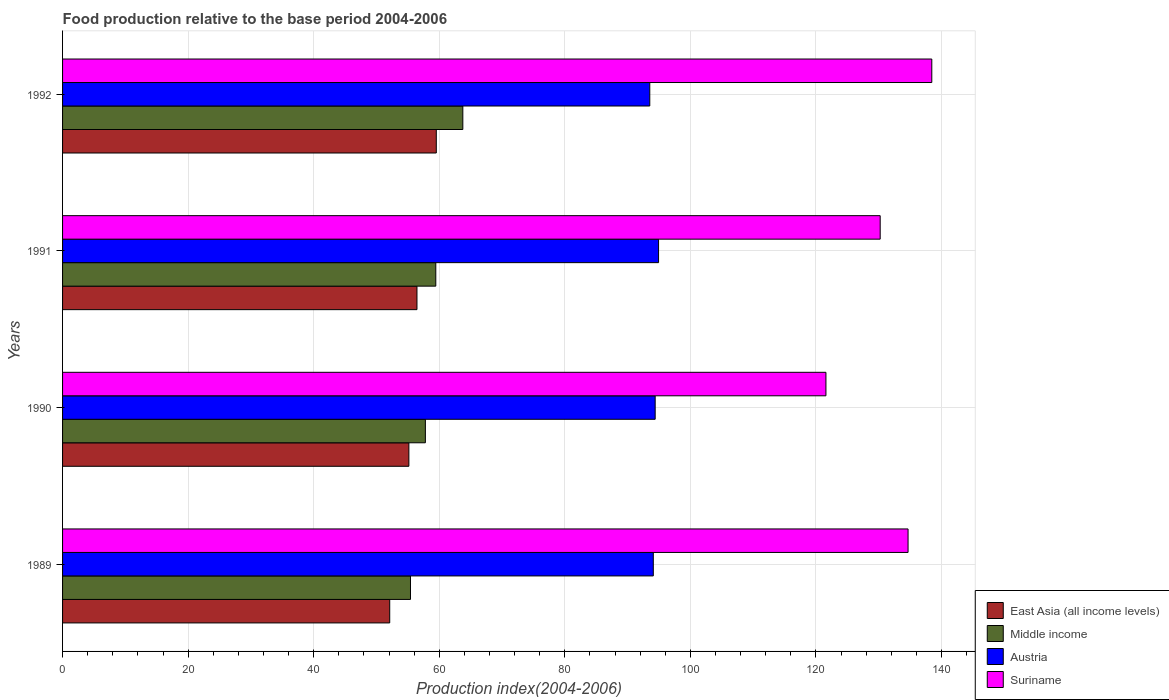How many groups of bars are there?
Your response must be concise. 4. Are the number of bars per tick equal to the number of legend labels?
Provide a short and direct response. Yes. Are the number of bars on each tick of the Y-axis equal?
Your answer should be very brief. Yes. How many bars are there on the 3rd tick from the top?
Offer a terse response. 4. What is the food production index in Suriname in 1991?
Offer a very short reply. 130.23. Across all years, what is the maximum food production index in East Asia (all income levels)?
Keep it short and to the point. 59.53. Across all years, what is the minimum food production index in Austria?
Your answer should be very brief. 93.53. What is the total food production index in Austria in the graph?
Keep it short and to the point. 376.94. What is the difference between the food production index in East Asia (all income levels) in 1991 and that in 1992?
Provide a succinct answer. -3.08. What is the difference between the food production index in Suriname in 1991 and the food production index in East Asia (all income levels) in 1989?
Offer a terse response. 78.12. What is the average food production index in Suriname per year?
Your answer should be compact. 131.24. In the year 1990, what is the difference between the food production index in Middle income and food production index in Austria?
Your response must be concise. -36.6. What is the ratio of the food production index in Suriname in 1990 to that in 1991?
Keep it short and to the point. 0.93. Is the difference between the food production index in Middle income in 1990 and 1991 greater than the difference between the food production index in Austria in 1990 and 1991?
Offer a very short reply. No. What is the difference between the highest and the second highest food production index in Suriname?
Offer a terse response. 3.78. What is the difference between the highest and the lowest food production index in Suriname?
Give a very brief answer. 16.86. Is the sum of the food production index in Middle income in 1989 and 1990 greater than the maximum food production index in Suriname across all years?
Provide a short and direct response. No. Is it the case that in every year, the sum of the food production index in Middle income and food production index in East Asia (all income levels) is greater than the sum of food production index in Suriname and food production index in Austria?
Your response must be concise. No. What does the 4th bar from the top in 1989 represents?
Make the answer very short. East Asia (all income levels). What does the 1st bar from the bottom in 1990 represents?
Make the answer very short. East Asia (all income levels). How many years are there in the graph?
Your answer should be very brief. 4. What is the difference between two consecutive major ticks on the X-axis?
Offer a very short reply. 20. Are the values on the major ticks of X-axis written in scientific E-notation?
Provide a short and direct response. No. How many legend labels are there?
Your response must be concise. 4. What is the title of the graph?
Keep it short and to the point. Food production relative to the base period 2004-2006. What is the label or title of the X-axis?
Ensure brevity in your answer.  Production index(2004-2006). What is the Production index(2004-2006) of East Asia (all income levels) in 1989?
Ensure brevity in your answer.  52.11. What is the Production index(2004-2006) of Middle income in 1989?
Your answer should be compact. 55.42. What is the Production index(2004-2006) in Austria in 1989?
Ensure brevity in your answer.  94.09. What is the Production index(2004-2006) in Suriname in 1989?
Keep it short and to the point. 134.67. What is the Production index(2004-2006) of East Asia (all income levels) in 1990?
Offer a terse response. 55.16. What is the Production index(2004-2006) of Middle income in 1990?
Provide a succinct answer. 57.79. What is the Production index(2004-2006) in Austria in 1990?
Give a very brief answer. 94.39. What is the Production index(2004-2006) of Suriname in 1990?
Your answer should be compact. 121.59. What is the Production index(2004-2006) of East Asia (all income levels) in 1991?
Provide a short and direct response. 56.45. What is the Production index(2004-2006) of Middle income in 1991?
Give a very brief answer. 59.45. What is the Production index(2004-2006) in Austria in 1991?
Give a very brief answer. 94.93. What is the Production index(2004-2006) of Suriname in 1991?
Your answer should be compact. 130.23. What is the Production index(2004-2006) of East Asia (all income levels) in 1992?
Provide a succinct answer. 59.53. What is the Production index(2004-2006) in Middle income in 1992?
Give a very brief answer. 63.75. What is the Production index(2004-2006) of Austria in 1992?
Provide a short and direct response. 93.53. What is the Production index(2004-2006) in Suriname in 1992?
Offer a terse response. 138.45. Across all years, what is the maximum Production index(2004-2006) in East Asia (all income levels)?
Offer a very short reply. 59.53. Across all years, what is the maximum Production index(2004-2006) of Middle income?
Make the answer very short. 63.75. Across all years, what is the maximum Production index(2004-2006) in Austria?
Make the answer very short. 94.93. Across all years, what is the maximum Production index(2004-2006) of Suriname?
Offer a very short reply. 138.45. Across all years, what is the minimum Production index(2004-2006) in East Asia (all income levels)?
Offer a very short reply. 52.11. Across all years, what is the minimum Production index(2004-2006) in Middle income?
Provide a short and direct response. 55.42. Across all years, what is the minimum Production index(2004-2006) in Austria?
Offer a very short reply. 93.53. Across all years, what is the minimum Production index(2004-2006) of Suriname?
Offer a very short reply. 121.59. What is the total Production index(2004-2006) in East Asia (all income levels) in the graph?
Your answer should be compact. 223.24. What is the total Production index(2004-2006) in Middle income in the graph?
Give a very brief answer. 236.41. What is the total Production index(2004-2006) in Austria in the graph?
Provide a short and direct response. 376.94. What is the total Production index(2004-2006) in Suriname in the graph?
Offer a very short reply. 524.94. What is the difference between the Production index(2004-2006) of East Asia (all income levels) in 1989 and that in 1990?
Give a very brief answer. -3.05. What is the difference between the Production index(2004-2006) of Middle income in 1989 and that in 1990?
Provide a short and direct response. -2.37. What is the difference between the Production index(2004-2006) in Suriname in 1989 and that in 1990?
Provide a succinct answer. 13.08. What is the difference between the Production index(2004-2006) of East Asia (all income levels) in 1989 and that in 1991?
Provide a short and direct response. -4.34. What is the difference between the Production index(2004-2006) in Middle income in 1989 and that in 1991?
Your answer should be very brief. -4.03. What is the difference between the Production index(2004-2006) of Austria in 1989 and that in 1991?
Your answer should be compact. -0.84. What is the difference between the Production index(2004-2006) in Suriname in 1989 and that in 1991?
Make the answer very short. 4.44. What is the difference between the Production index(2004-2006) in East Asia (all income levels) in 1989 and that in 1992?
Ensure brevity in your answer.  -7.42. What is the difference between the Production index(2004-2006) of Middle income in 1989 and that in 1992?
Provide a short and direct response. -8.34. What is the difference between the Production index(2004-2006) of Austria in 1989 and that in 1992?
Your answer should be compact. 0.56. What is the difference between the Production index(2004-2006) in Suriname in 1989 and that in 1992?
Your response must be concise. -3.78. What is the difference between the Production index(2004-2006) of East Asia (all income levels) in 1990 and that in 1991?
Provide a succinct answer. -1.29. What is the difference between the Production index(2004-2006) in Middle income in 1990 and that in 1991?
Offer a very short reply. -1.66. What is the difference between the Production index(2004-2006) of Austria in 1990 and that in 1991?
Your answer should be very brief. -0.54. What is the difference between the Production index(2004-2006) of Suriname in 1990 and that in 1991?
Provide a succinct answer. -8.64. What is the difference between the Production index(2004-2006) in East Asia (all income levels) in 1990 and that in 1992?
Provide a short and direct response. -4.37. What is the difference between the Production index(2004-2006) of Middle income in 1990 and that in 1992?
Your answer should be very brief. -5.97. What is the difference between the Production index(2004-2006) in Austria in 1990 and that in 1992?
Your answer should be compact. 0.86. What is the difference between the Production index(2004-2006) of Suriname in 1990 and that in 1992?
Your answer should be compact. -16.86. What is the difference between the Production index(2004-2006) in East Asia (all income levels) in 1991 and that in 1992?
Give a very brief answer. -3.08. What is the difference between the Production index(2004-2006) of Middle income in 1991 and that in 1992?
Ensure brevity in your answer.  -4.3. What is the difference between the Production index(2004-2006) in Austria in 1991 and that in 1992?
Give a very brief answer. 1.4. What is the difference between the Production index(2004-2006) of Suriname in 1991 and that in 1992?
Make the answer very short. -8.22. What is the difference between the Production index(2004-2006) of East Asia (all income levels) in 1989 and the Production index(2004-2006) of Middle income in 1990?
Offer a very short reply. -5.68. What is the difference between the Production index(2004-2006) of East Asia (all income levels) in 1989 and the Production index(2004-2006) of Austria in 1990?
Provide a succinct answer. -42.28. What is the difference between the Production index(2004-2006) in East Asia (all income levels) in 1989 and the Production index(2004-2006) in Suriname in 1990?
Keep it short and to the point. -69.48. What is the difference between the Production index(2004-2006) of Middle income in 1989 and the Production index(2004-2006) of Austria in 1990?
Ensure brevity in your answer.  -38.97. What is the difference between the Production index(2004-2006) of Middle income in 1989 and the Production index(2004-2006) of Suriname in 1990?
Your answer should be compact. -66.17. What is the difference between the Production index(2004-2006) of Austria in 1989 and the Production index(2004-2006) of Suriname in 1990?
Your response must be concise. -27.5. What is the difference between the Production index(2004-2006) in East Asia (all income levels) in 1989 and the Production index(2004-2006) in Middle income in 1991?
Give a very brief answer. -7.34. What is the difference between the Production index(2004-2006) in East Asia (all income levels) in 1989 and the Production index(2004-2006) in Austria in 1991?
Keep it short and to the point. -42.82. What is the difference between the Production index(2004-2006) in East Asia (all income levels) in 1989 and the Production index(2004-2006) in Suriname in 1991?
Provide a short and direct response. -78.12. What is the difference between the Production index(2004-2006) of Middle income in 1989 and the Production index(2004-2006) of Austria in 1991?
Offer a very short reply. -39.51. What is the difference between the Production index(2004-2006) of Middle income in 1989 and the Production index(2004-2006) of Suriname in 1991?
Your response must be concise. -74.81. What is the difference between the Production index(2004-2006) of Austria in 1989 and the Production index(2004-2006) of Suriname in 1991?
Offer a terse response. -36.14. What is the difference between the Production index(2004-2006) of East Asia (all income levels) in 1989 and the Production index(2004-2006) of Middle income in 1992?
Provide a succinct answer. -11.64. What is the difference between the Production index(2004-2006) of East Asia (all income levels) in 1989 and the Production index(2004-2006) of Austria in 1992?
Your answer should be compact. -41.42. What is the difference between the Production index(2004-2006) of East Asia (all income levels) in 1989 and the Production index(2004-2006) of Suriname in 1992?
Your response must be concise. -86.34. What is the difference between the Production index(2004-2006) of Middle income in 1989 and the Production index(2004-2006) of Austria in 1992?
Your response must be concise. -38.11. What is the difference between the Production index(2004-2006) in Middle income in 1989 and the Production index(2004-2006) in Suriname in 1992?
Your response must be concise. -83.03. What is the difference between the Production index(2004-2006) in Austria in 1989 and the Production index(2004-2006) in Suriname in 1992?
Make the answer very short. -44.36. What is the difference between the Production index(2004-2006) of East Asia (all income levels) in 1990 and the Production index(2004-2006) of Middle income in 1991?
Give a very brief answer. -4.29. What is the difference between the Production index(2004-2006) of East Asia (all income levels) in 1990 and the Production index(2004-2006) of Austria in 1991?
Provide a succinct answer. -39.77. What is the difference between the Production index(2004-2006) of East Asia (all income levels) in 1990 and the Production index(2004-2006) of Suriname in 1991?
Offer a very short reply. -75.07. What is the difference between the Production index(2004-2006) of Middle income in 1990 and the Production index(2004-2006) of Austria in 1991?
Offer a terse response. -37.14. What is the difference between the Production index(2004-2006) of Middle income in 1990 and the Production index(2004-2006) of Suriname in 1991?
Offer a very short reply. -72.44. What is the difference between the Production index(2004-2006) in Austria in 1990 and the Production index(2004-2006) in Suriname in 1991?
Ensure brevity in your answer.  -35.84. What is the difference between the Production index(2004-2006) of East Asia (all income levels) in 1990 and the Production index(2004-2006) of Middle income in 1992?
Make the answer very short. -8.59. What is the difference between the Production index(2004-2006) of East Asia (all income levels) in 1990 and the Production index(2004-2006) of Austria in 1992?
Provide a short and direct response. -38.37. What is the difference between the Production index(2004-2006) of East Asia (all income levels) in 1990 and the Production index(2004-2006) of Suriname in 1992?
Keep it short and to the point. -83.29. What is the difference between the Production index(2004-2006) of Middle income in 1990 and the Production index(2004-2006) of Austria in 1992?
Your response must be concise. -35.74. What is the difference between the Production index(2004-2006) in Middle income in 1990 and the Production index(2004-2006) in Suriname in 1992?
Give a very brief answer. -80.66. What is the difference between the Production index(2004-2006) in Austria in 1990 and the Production index(2004-2006) in Suriname in 1992?
Ensure brevity in your answer.  -44.06. What is the difference between the Production index(2004-2006) of East Asia (all income levels) in 1991 and the Production index(2004-2006) of Middle income in 1992?
Provide a short and direct response. -7.3. What is the difference between the Production index(2004-2006) in East Asia (all income levels) in 1991 and the Production index(2004-2006) in Austria in 1992?
Provide a short and direct response. -37.08. What is the difference between the Production index(2004-2006) of East Asia (all income levels) in 1991 and the Production index(2004-2006) of Suriname in 1992?
Provide a succinct answer. -82. What is the difference between the Production index(2004-2006) in Middle income in 1991 and the Production index(2004-2006) in Austria in 1992?
Ensure brevity in your answer.  -34.08. What is the difference between the Production index(2004-2006) in Middle income in 1991 and the Production index(2004-2006) in Suriname in 1992?
Offer a very short reply. -79. What is the difference between the Production index(2004-2006) in Austria in 1991 and the Production index(2004-2006) in Suriname in 1992?
Keep it short and to the point. -43.52. What is the average Production index(2004-2006) of East Asia (all income levels) per year?
Offer a very short reply. 55.81. What is the average Production index(2004-2006) of Middle income per year?
Ensure brevity in your answer.  59.1. What is the average Production index(2004-2006) of Austria per year?
Make the answer very short. 94.23. What is the average Production index(2004-2006) of Suriname per year?
Ensure brevity in your answer.  131.24. In the year 1989, what is the difference between the Production index(2004-2006) of East Asia (all income levels) and Production index(2004-2006) of Middle income?
Your answer should be very brief. -3.31. In the year 1989, what is the difference between the Production index(2004-2006) in East Asia (all income levels) and Production index(2004-2006) in Austria?
Keep it short and to the point. -41.98. In the year 1989, what is the difference between the Production index(2004-2006) in East Asia (all income levels) and Production index(2004-2006) in Suriname?
Offer a very short reply. -82.56. In the year 1989, what is the difference between the Production index(2004-2006) of Middle income and Production index(2004-2006) of Austria?
Ensure brevity in your answer.  -38.67. In the year 1989, what is the difference between the Production index(2004-2006) of Middle income and Production index(2004-2006) of Suriname?
Ensure brevity in your answer.  -79.25. In the year 1989, what is the difference between the Production index(2004-2006) in Austria and Production index(2004-2006) in Suriname?
Your response must be concise. -40.58. In the year 1990, what is the difference between the Production index(2004-2006) of East Asia (all income levels) and Production index(2004-2006) of Middle income?
Offer a very short reply. -2.63. In the year 1990, what is the difference between the Production index(2004-2006) in East Asia (all income levels) and Production index(2004-2006) in Austria?
Your answer should be very brief. -39.23. In the year 1990, what is the difference between the Production index(2004-2006) in East Asia (all income levels) and Production index(2004-2006) in Suriname?
Your response must be concise. -66.43. In the year 1990, what is the difference between the Production index(2004-2006) of Middle income and Production index(2004-2006) of Austria?
Your answer should be very brief. -36.6. In the year 1990, what is the difference between the Production index(2004-2006) of Middle income and Production index(2004-2006) of Suriname?
Offer a very short reply. -63.8. In the year 1990, what is the difference between the Production index(2004-2006) of Austria and Production index(2004-2006) of Suriname?
Offer a very short reply. -27.2. In the year 1991, what is the difference between the Production index(2004-2006) in East Asia (all income levels) and Production index(2004-2006) in Austria?
Ensure brevity in your answer.  -38.48. In the year 1991, what is the difference between the Production index(2004-2006) of East Asia (all income levels) and Production index(2004-2006) of Suriname?
Keep it short and to the point. -73.78. In the year 1991, what is the difference between the Production index(2004-2006) of Middle income and Production index(2004-2006) of Austria?
Give a very brief answer. -35.48. In the year 1991, what is the difference between the Production index(2004-2006) of Middle income and Production index(2004-2006) of Suriname?
Offer a very short reply. -70.78. In the year 1991, what is the difference between the Production index(2004-2006) in Austria and Production index(2004-2006) in Suriname?
Offer a terse response. -35.3. In the year 1992, what is the difference between the Production index(2004-2006) of East Asia (all income levels) and Production index(2004-2006) of Middle income?
Ensure brevity in your answer.  -4.23. In the year 1992, what is the difference between the Production index(2004-2006) in East Asia (all income levels) and Production index(2004-2006) in Austria?
Give a very brief answer. -34. In the year 1992, what is the difference between the Production index(2004-2006) of East Asia (all income levels) and Production index(2004-2006) of Suriname?
Offer a terse response. -78.92. In the year 1992, what is the difference between the Production index(2004-2006) in Middle income and Production index(2004-2006) in Austria?
Make the answer very short. -29.78. In the year 1992, what is the difference between the Production index(2004-2006) of Middle income and Production index(2004-2006) of Suriname?
Your answer should be compact. -74.7. In the year 1992, what is the difference between the Production index(2004-2006) of Austria and Production index(2004-2006) of Suriname?
Your response must be concise. -44.92. What is the ratio of the Production index(2004-2006) of East Asia (all income levels) in 1989 to that in 1990?
Your answer should be very brief. 0.94. What is the ratio of the Production index(2004-2006) of Middle income in 1989 to that in 1990?
Your response must be concise. 0.96. What is the ratio of the Production index(2004-2006) in Suriname in 1989 to that in 1990?
Offer a very short reply. 1.11. What is the ratio of the Production index(2004-2006) in Middle income in 1989 to that in 1991?
Ensure brevity in your answer.  0.93. What is the ratio of the Production index(2004-2006) of Austria in 1989 to that in 1991?
Give a very brief answer. 0.99. What is the ratio of the Production index(2004-2006) of Suriname in 1989 to that in 1991?
Provide a succinct answer. 1.03. What is the ratio of the Production index(2004-2006) in East Asia (all income levels) in 1989 to that in 1992?
Ensure brevity in your answer.  0.88. What is the ratio of the Production index(2004-2006) of Middle income in 1989 to that in 1992?
Keep it short and to the point. 0.87. What is the ratio of the Production index(2004-2006) of Suriname in 1989 to that in 1992?
Offer a very short reply. 0.97. What is the ratio of the Production index(2004-2006) of East Asia (all income levels) in 1990 to that in 1991?
Give a very brief answer. 0.98. What is the ratio of the Production index(2004-2006) of Middle income in 1990 to that in 1991?
Ensure brevity in your answer.  0.97. What is the ratio of the Production index(2004-2006) of Austria in 1990 to that in 1991?
Offer a very short reply. 0.99. What is the ratio of the Production index(2004-2006) in Suriname in 1990 to that in 1991?
Provide a succinct answer. 0.93. What is the ratio of the Production index(2004-2006) in East Asia (all income levels) in 1990 to that in 1992?
Provide a short and direct response. 0.93. What is the ratio of the Production index(2004-2006) in Middle income in 1990 to that in 1992?
Your answer should be very brief. 0.91. What is the ratio of the Production index(2004-2006) in Austria in 1990 to that in 1992?
Give a very brief answer. 1.01. What is the ratio of the Production index(2004-2006) in Suriname in 1990 to that in 1992?
Provide a short and direct response. 0.88. What is the ratio of the Production index(2004-2006) in East Asia (all income levels) in 1991 to that in 1992?
Your answer should be very brief. 0.95. What is the ratio of the Production index(2004-2006) of Middle income in 1991 to that in 1992?
Your answer should be compact. 0.93. What is the ratio of the Production index(2004-2006) in Austria in 1991 to that in 1992?
Ensure brevity in your answer.  1.01. What is the ratio of the Production index(2004-2006) of Suriname in 1991 to that in 1992?
Your answer should be compact. 0.94. What is the difference between the highest and the second highest Production index(2004-2006) of East Asia (all income levels)?
Make the answer very short. 3.08. What is the difference between the highest and the second highest Production index(2004-2006) of Middle income?
Give a very brief answer. 4.3. What is the difference between the highest and the second highest Production index(2004-2006) of Austria?
Offer a terse response. 0.54. What is the difference between the highest and the second highest Production index(2004-2006) of Suriname?
Make the answer very short. 3.78. What is the difference between the highest and the lowest Production index(2004-2006) of East Asia (all income levels)?
Provide a short and direct response. 7.42. What is the difference between the highest and the lowest Production index(2004-2006) of Middle income?
Ensure brevity in your answer.  8.34. What is the difference between the highest and the lowest Production index(2004-2006) of Suriname?
Ensure brevity in your answer.  16.86. 